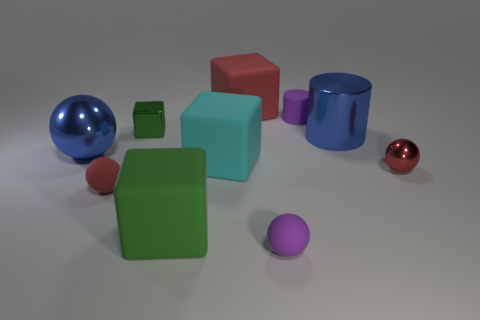Subtract 1 cubes. How many cubes are left? 3 Subtract all yellow blocks. Subtract all cyan spheres. How many blocks are left? 4 Subtract all balls. How many objects are left? 6 Add 5 purple metal blocks. How many purple metal blocks exist? 5 Subtract 1 blue spheres. How many objects are left? 9 Subtract all green metallic cubes. Subtract all large green matte cubes. How many objects are left? 8 Add 7 red blocks. How many red blocks are left? 8 